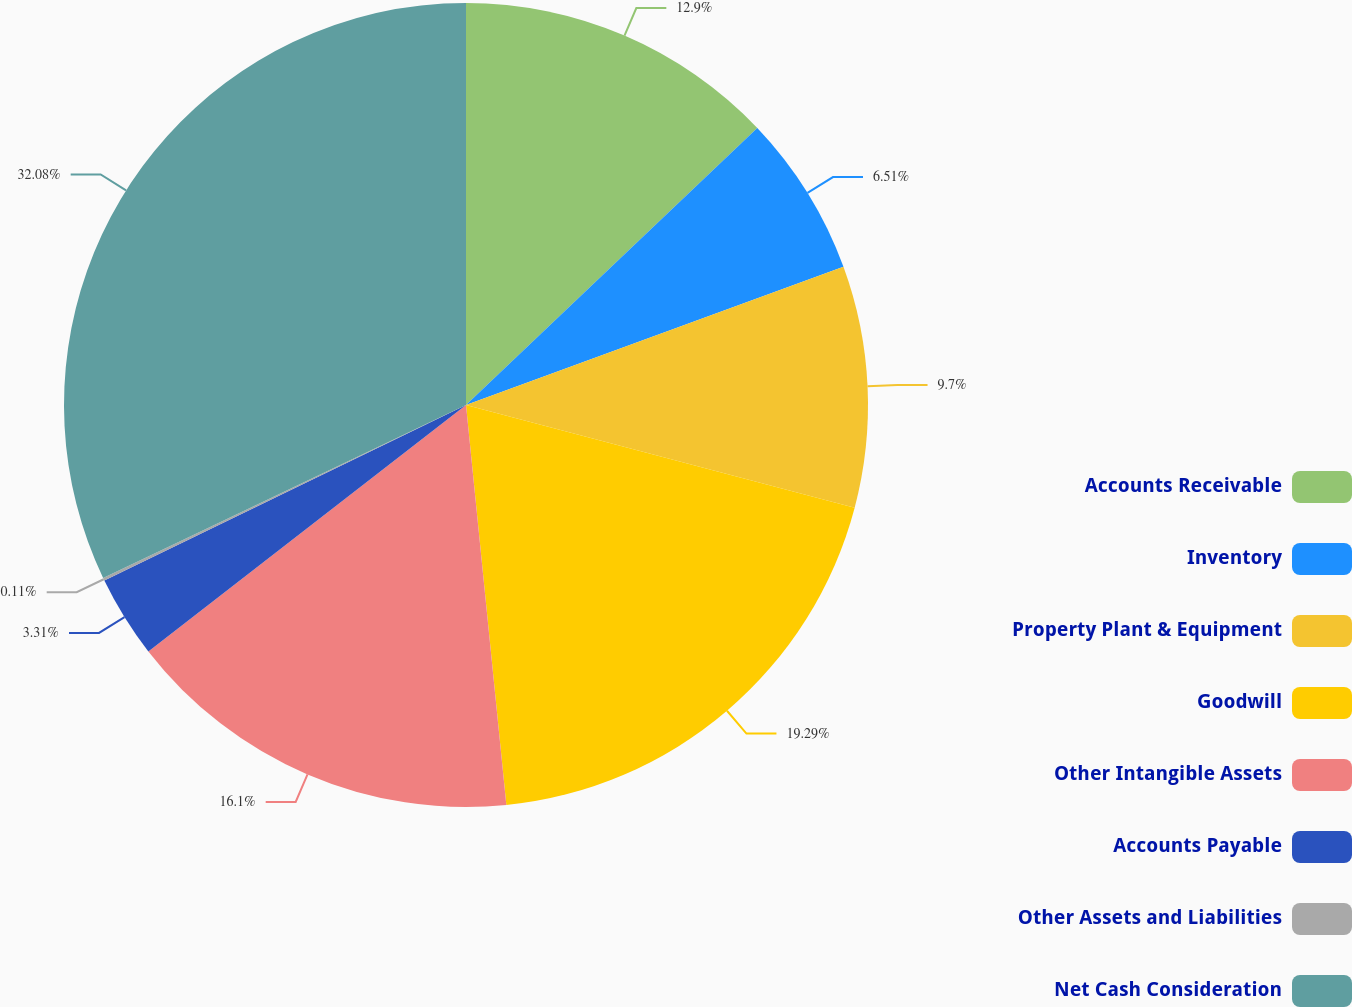Convert chart to OTSL. <chart><loc_0><loc_0><loc_500><loc_500><pie_chart><fcel>Accounts Receivable<fcel>Inventory<fcel>Property Plant & Equipment<fcel>Goodwill<fcel>Other Intangible Assets<fcel>Accounts Payable<fcel>Other Assets and Liabilities<fcel>Net Cash Consideration<nl><fcel>12.9%<fcel>6.51%<fcel>9.7%<fcel>19.29%<fcel>16.1%<fcel>3.31%<fcel>0.11%<fcel>32.08%<nl></chart> 